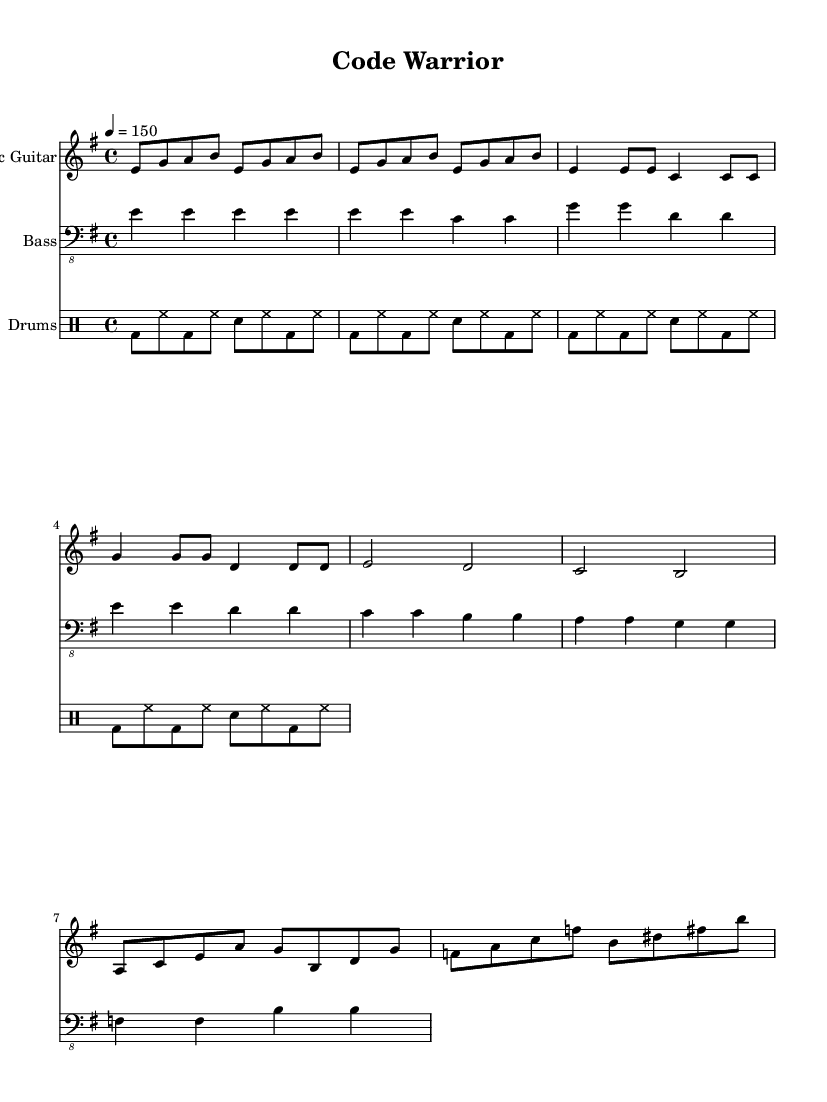What is the key signature of this music? The key signature is E minor, which has one sharp (F#). This can be observed by looking at the key signature section at the beginning of the music.
Answer: E minor What is the time signature of this music? The time signature is 4/4, which means there are four beats in each measure. This is indicated at the beginning of the score where the time signature is prominently displayed.
Answer: 4/4 What is the tempo marking of this music? The tempo marking is 150 beats per minute, indicated by "4 = 150" at the beginning, which specifies the speed at which the music should be played.
Answer: 150 How many measures are in the chorus? The chorus consists of 4 measures, as seen by counting the measures in the chorus section where the music indicates two measures for each line of the lyrics.
Answer: 4 What is the primary instrument used in this tune? The primary instrument for this piece is the electric guitar, as indicated by the first staff labeled "Electric Guitar." This shows its prominence in the arrangement.
Answer: Electric Guitar Describe the rhythm style used in the drums. The rhythm style used is a basic rock beat, characterized by the pattern of bass drum (bd), hi-hat (hh), and snare (sn) repeated in eighth notes, which is standard in hard rock music for creating energetic rhythms.
Answer: Basic rock beat How many times is the intro section repeated? The intro section is repeated 4 times, as indicated by the directive "repeat unfold 4," meaning that the preceding notes should be played a total of four times.
Answer: 4 